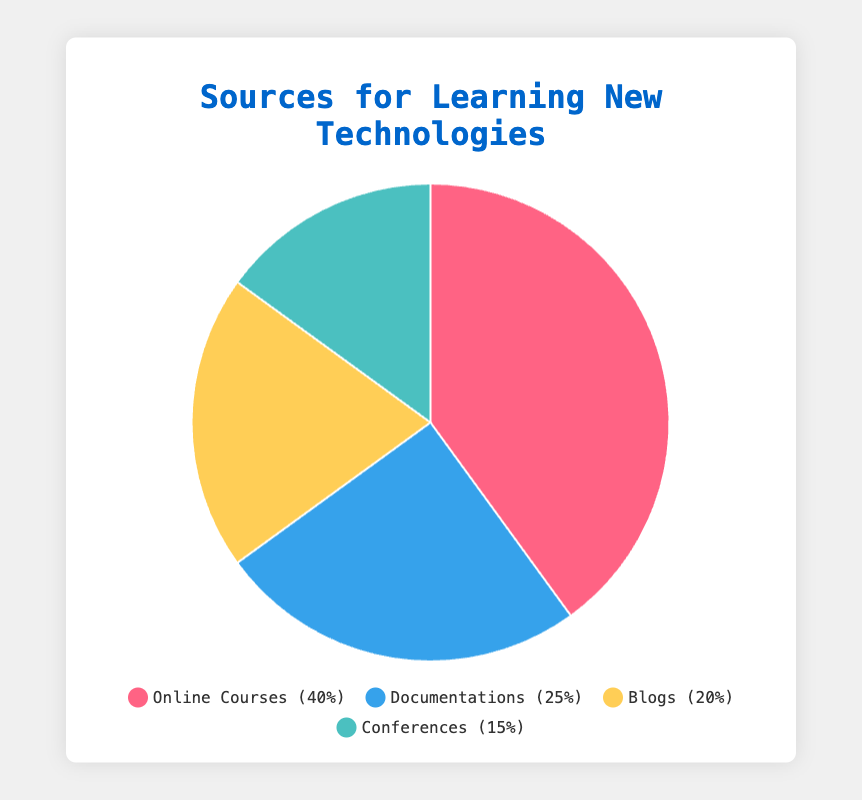Which source has the largest percentage for learning new technologies? Observing the pie chart, the largest segment is for "Online Courses" with 40%.
Answer: Online Courses What is the percentage difference between the most and least popular sources for learning new technologies? The most popular source is "Online Courses" at 40%, and the least popular is "Conferences" at 15%. The difference is 40% - 15% = 25%.
Answer: 25% Which two sources combined make up 45% of the total responses? Combining "Documentations" (25%) and "Conferences" (15%) gives (25% + 15% = 40%), which is too low. Combining "Blogs" (20%) and "Conferences" (15%) gives (20% + 15% = 35%), also too low. Combining "Blogs" (20%) and "Documentations" (25%) gives (20% + 25% = 45%), which is correct.
Answer: Blogs and Documentations If you group Online Courses and Documentations together, what percentage of the total do they represent? "Online Courses" represent 40% and "Documentations" represent 25%. Their combined total is 40% + 25% = 65%.
Answer: 65% Which source has a segment colored blue in the pie chart? Looking at the visual attributes, the segment colored blue represents "Documentations".
Answer: Documentations What is the ratio of the percentage of Online Courses to Blogs? The percentage for "Online Courses" is 40%, and for "Blogs" it is 20%. The ratio is 40% : 20%, which simplifies to 2:1.
Answer: 2:1 How many sources exceed 20%? "Online Courses" (40%) and "Documentations" (25%) both exceed 20%, resulting in 2 sources.
Answer: 2 Compare the combined percentage of "Documentations" and "Conferences" to the percentage of "Online Courses". Which is greater? "Documentations" (25%) + "Conferences" (15%) = 40%. "Online Courses" also have 40%, so they are equal.
Answer: They are equal What is the average percentage of all sources for learning new technologies? The total percentage is 100% divided by the 4 sources (40% + 25% + 20% + 15%) which sums to 100%. Thus, 100% / 4 = 25%.
Answer: 25% 